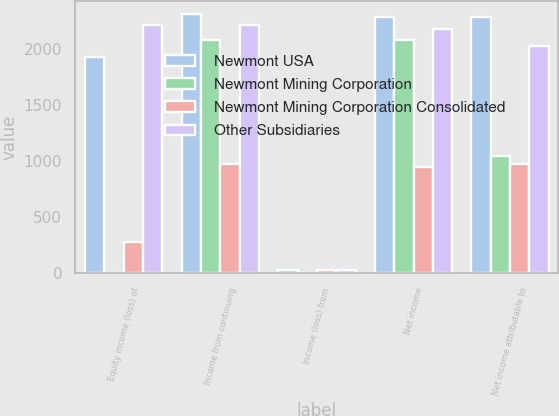Convert chart to OTSL. <chart><loc_0><loc_0><loc_500><loc_500><stacked_bar_chart><ecel><fcel>Equity income (loss) of<fcel>Income from continuing<fcel>Income (loss) from<fcel>Net income<fcel>Net income attributable to<nl><fcel>Newmont USA<fcel>1926<fcel>2305<fcel>28<fcel>2277<fcel>2277<nl><fcel>Newmont Mining Corporation<fcel>2<fcel>2072<fcel>2<fcel>2074<fcel>1048<nl><fcel>Newmont Mining Corporation Consolidated<fcel>281<fcel>973<fcel>30<fcel>943<fcel>977<nl><fcel>Other Subsidiaries<fcel>2206<fcel>2206<fcel>28<fcel>2178<fcel>2025<nl></chart> 